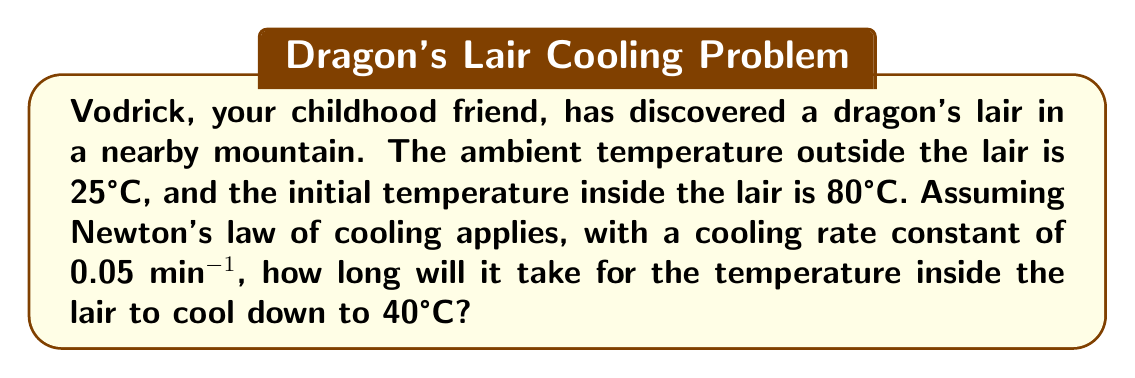Could you help me with this problem? To solve this problem, we'll use Newton's law of cooling, which states that the rate of change of temperature is proportional to the difference between the object's temperature and the ambient temperature.

The differential equation for Newton's law of cooling is:

$$\frac{dT}{dt} = -k(T - T_a)$$

Where:
- $T$ is the temperature of the object (in this case, the lair)
- $T_a$ is the ambient temperature
- $k$ is the cooling rate constant
- $t$ is time

Given:
- Initial temperature $T_0 = 80°C$
- Ambient temperature $T_a = 25°C$
- Final temperature $T = 40°C$
- Cooling rate constant $k = 0.05$ min^(-1)

The solution to this differential equation is:

$$T(t) = T_a + (T_0 - T_a)e^{-kt}$$

To find the time $t$, we need to solve:

$$40 = 25 + (80 - 25)e^{-0.05t}$$

Simplifying:

$$15 = 55e^{-0.05t}$$

Taking the natural logarithm of both sides:

$$\ln(\frac{15}{55}) = -0.05t$$

$$\ln(0.2727) = -0.05t$$

$$-1.2993 = -0.05t$$

Solving for $t$:

$$t = \frac{1.2993}{0.05} = 25.986 \text{ minutes}$$

Therefore, it will take approximately 25.99 minutes for the temperature inside the lair to cool down to 40°C.
Answer: 25.99 minutes 